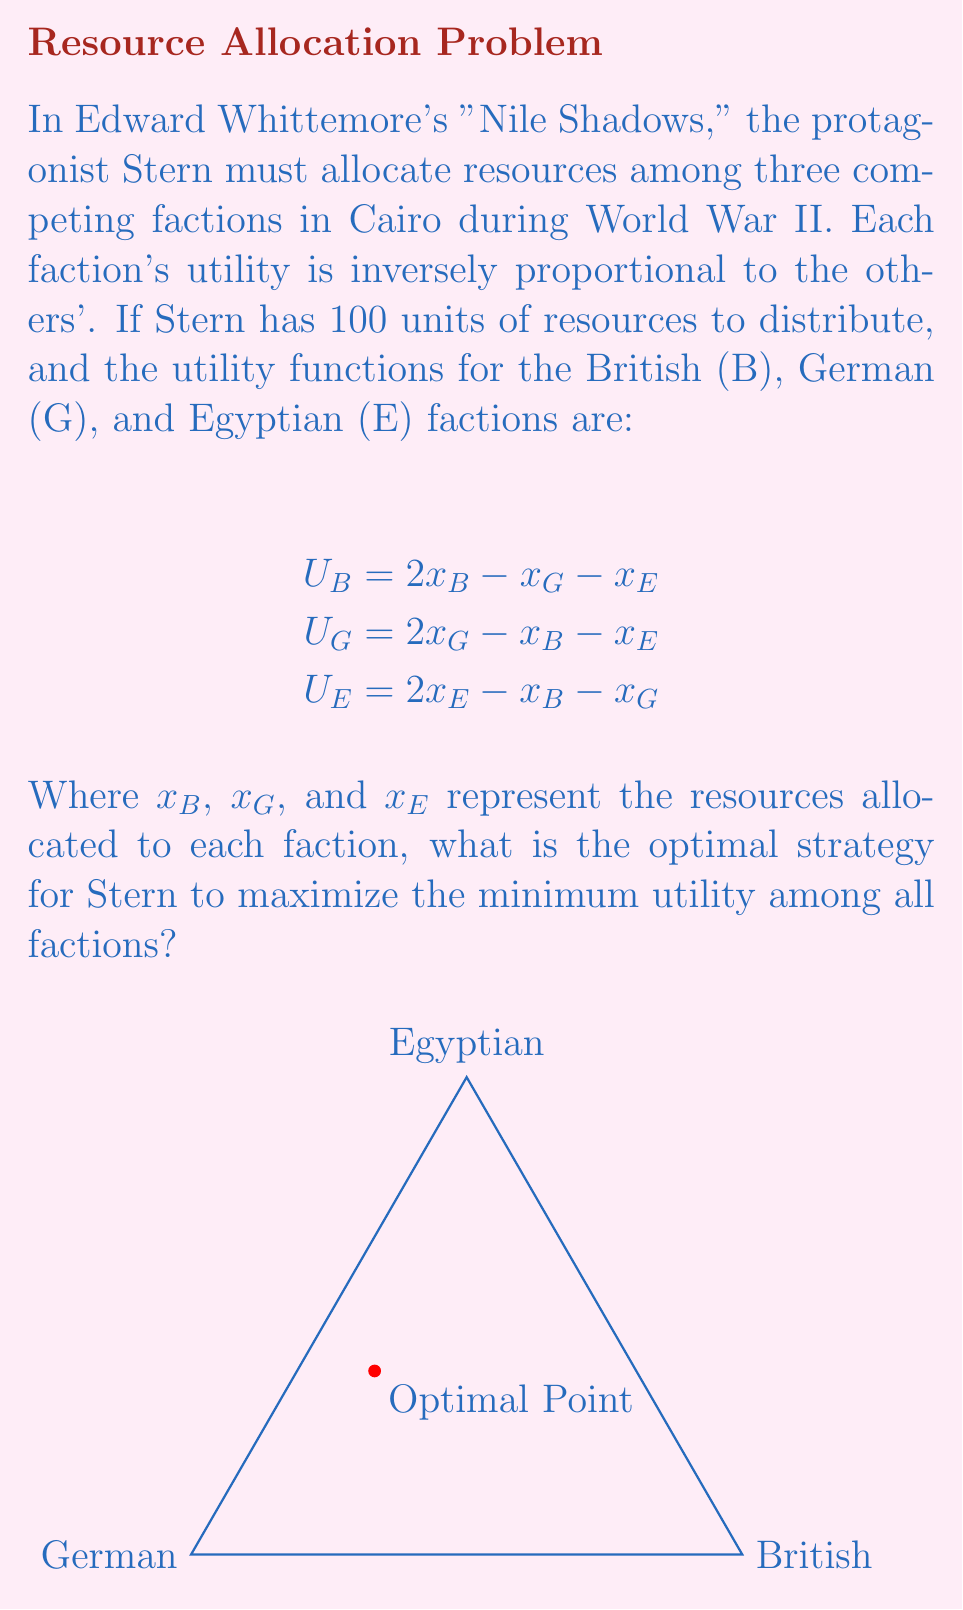Could you help me with this problem? To solve this problem, we can follow these steps:

1) First, we recognize that this is a zero-sum game, as the total utility is always zero:
   $U_B + U_G + U_E = (2x_B - x_G - x_E) + (2x_G - x_B - x_E) + (2x_E - x_B - x_G) = 0$

2) The constraint on total resources is:
   $x_B + x_G + x_E = 100$

3) To maximize the minimum utility, all utilities should be equal at the optimal point:
   $U_B = U_G = U_E$

4) This gives us the equations:
   $2x_B - x_G - x_E = 2x_G - x_B - x_E = 2x_E - x_B - x_G$

5) Solving these equations along with the resource constraint:
   $x_B = x_G = x_E = \frac{100}{3} \approx 33.33$

6) The utility for each faction at this point is:
   $U_B = U_G = U_E = 2(\frac{100}{3}) - \frac{100}{3} - \frac{100}{3} = 0$

7) This solution represents the Nash equilibrium of the game, where no faction can unilaterally improve their position.

8) The strategy is visually represented by the center point of the triangle in the diagram, indicating equal distribution among all factions.
Answer: Allocate $\frac{100}{3}$ units to each faction. 